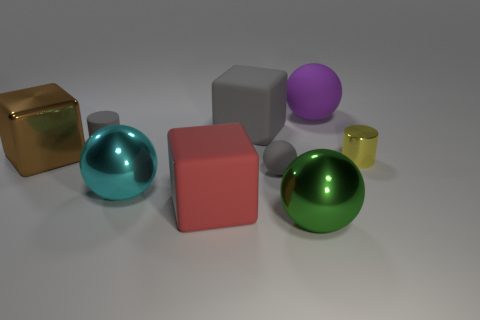There is a small cylinder that is the same color as the small sphere; what is it made of?
Offer a terse response. Rubber. There is a matte ball to the left of the large purple ball; is its color the same as the matte cube that is behind the large red rubber thing?
Offer a terse response. Yes. What shape is the tiny rubber thing that is behind the gray thing on the right side of the big gray matte thing?
Offer a terse response. Cylinder. There is a large brown shiny object; are there any gray spheres behind it?
Make the answer very short. No. What is the color of the rubber ball that is the same size as the yellow shiny thing?
Make the answer very short. Gray. How many gray blocks have the same material as the cyan ball?
Keep it short and to the point. 0. How many other things are there of the same size as the yellow metallic thing?
Offer a very short reply. 2. Are there any green balls of the same size as the cyan metallic thing?
Offer a terse response. Yes. Does the tiny thing behind the big brown shiny block have the same color as the small matte ball?
Keep it short and to the point. Yes. What number of objects are gray balls or big rubber cubes?
Your answer should be compact. 3. 